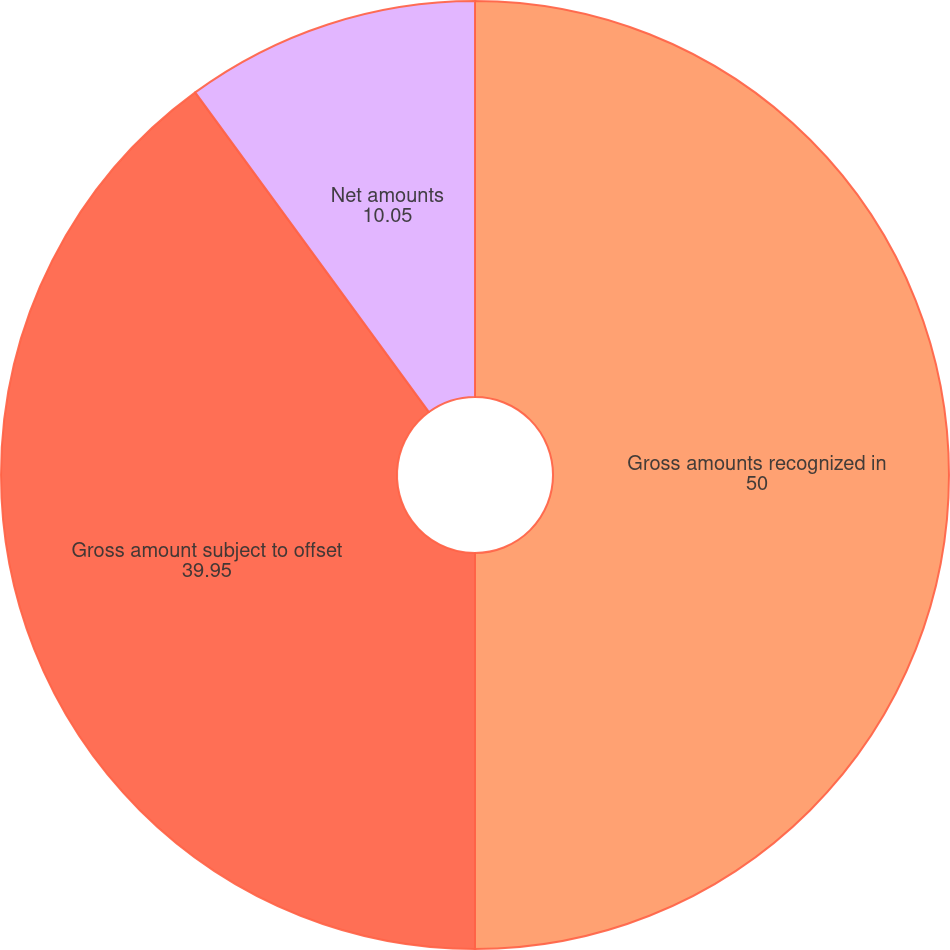Convert chart. <chart><loc_0><loc_0><loc_500><loc_500><pie_chart><fcel>Gross amounts recognized in<fcel>Gross amount subject to offset<fcel>Net amounts<nl><fcel>50.0%<fcel>39.95%<fcel>10.05%<nl></chart> 